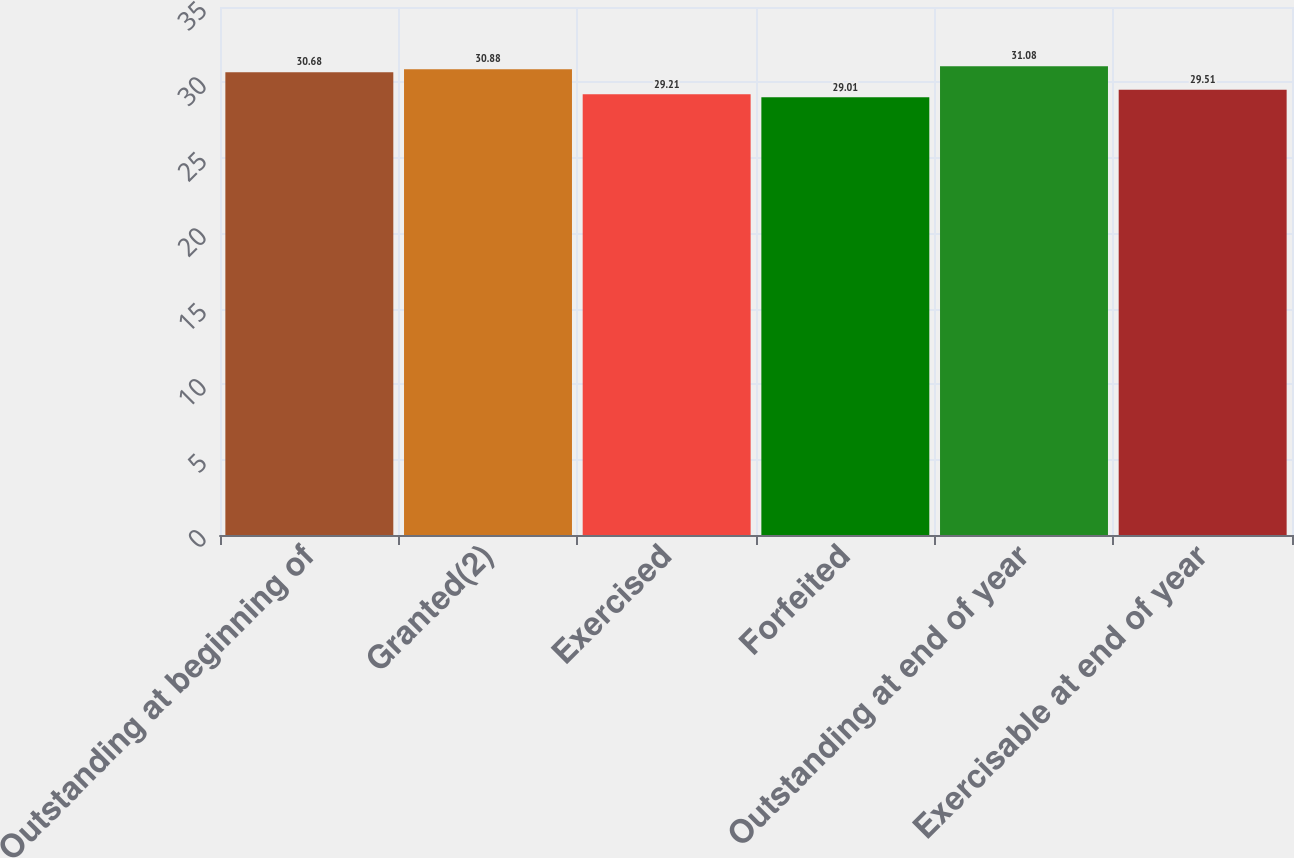Convert chart. <chart><loc_0><loc_0><loc_500><loc_500><bar_chart><fcel>Outstanding at beginning of<fcel>Granted(2)<fcel>Exercised<fcel>Forfeited<fcel>Outstanding at end of year<fcel>Exercisable at end of year<nl><fcel>30.68<fcel>30.88<fcel>29.21<fcel>29.01<fcel>31.08<fcel>29.51<nl></chart> 